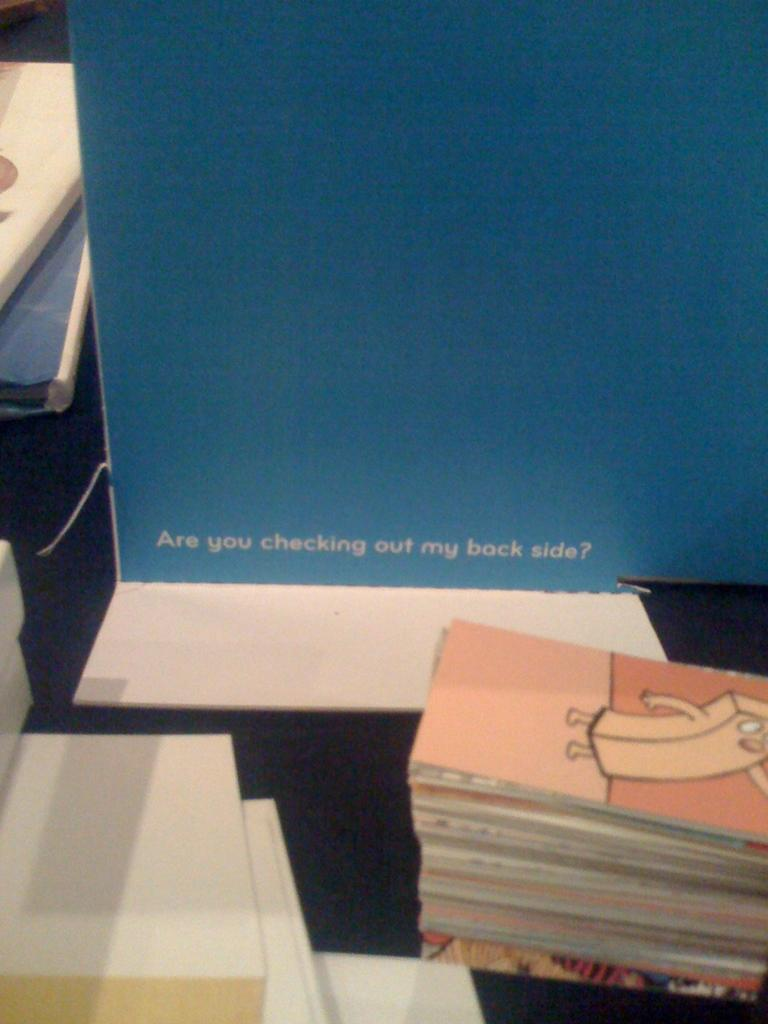<image>
Write a terse but informative summary of the picture. Stacks of books are in front of the question are you checking out my back side. 